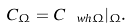Convert formula to latex. <formula><loc_0><loc_0><loc_500><loc_500>C _ { \Omega } = C _ { \ w h { \Omega } } | _ { \Omega } .</formula> 